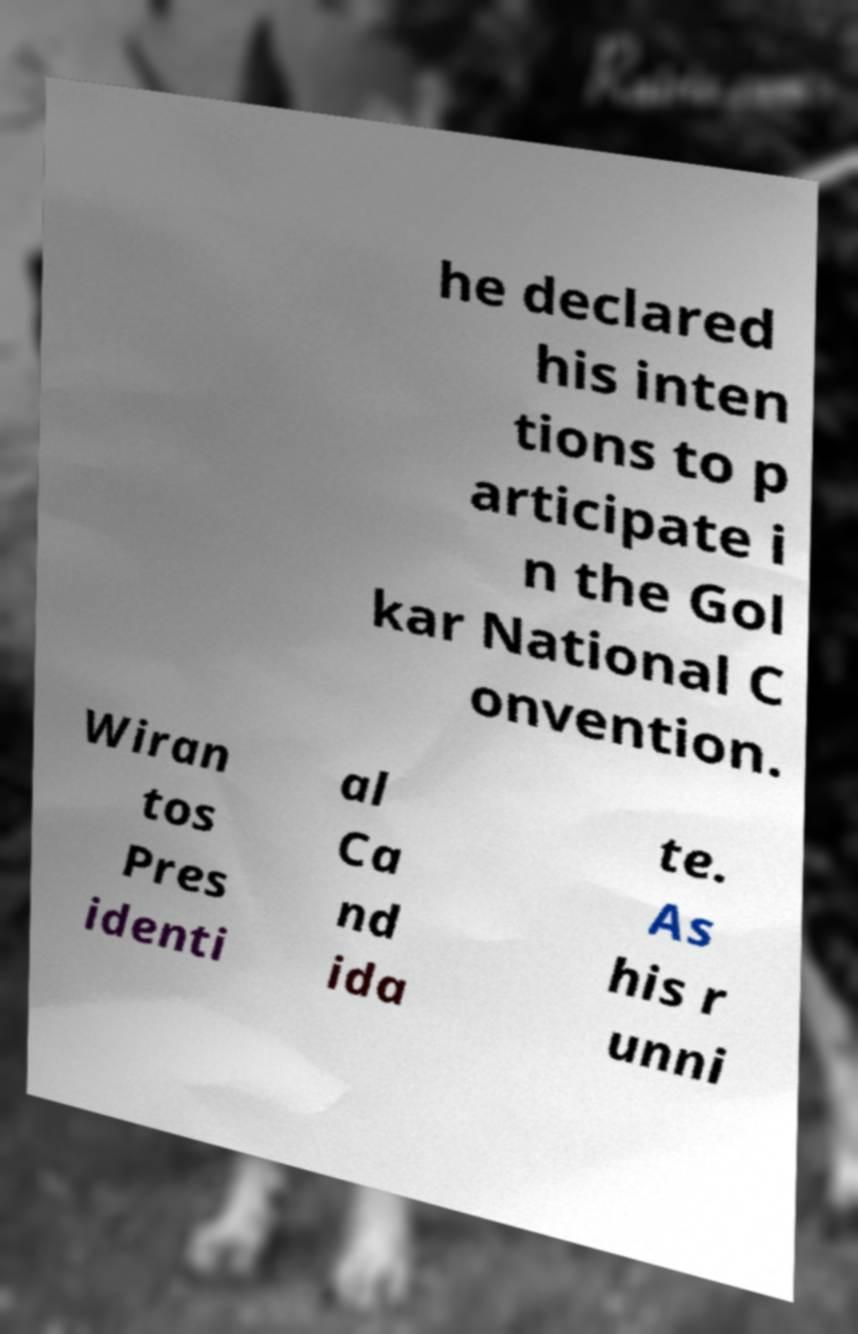What messages or text are displayed in this image? I need them in a readable, typed format. he declared his inten tions to p articipate i n the Gol kar National C onvention. Wiran tos Pres identi al Ca nd ida te. As his r unni 